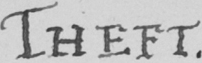Please provide the text content of this handwritten line. THEFT 